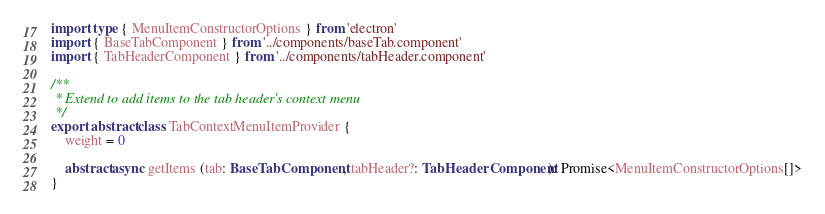Convert code to text. <code><loc_0><loc_0><loc_500><loc_500><_TypeScript_>import type { MenuItemConstructorOptions } from 'electron'
import { BaseTabComponent } from '../components/baseTab.component'
import { TabHeaderComponent } from '../components/tabHeader.component'

/**
 * Extend to add items to the tab header's context menu
 */
export abstract class TabContextMenuItemProvider {
    weight = 0

    abstract async getItems (tab: BaseTabComponent, tabHeader?: TabHeaderComponent): Promise<MenuItemConstructorOptions[]>
}
</code> 